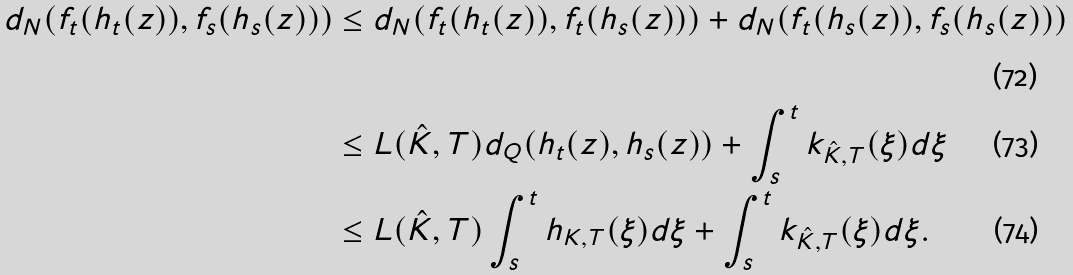<formula> <loc_0><loc_0><loc_500><loc_500>d _ { N } ( f _ { t } ( h _ { t } ( z ) ) , f _ { s } ( h _ { s } ( z ) ) ) & \leq d _ { N } ( f _ { t } ( h _ { t } ( z ) ) , f _ { t } ( h _ { s } ( z ) ) ) + d _ { N } ( f _ { t } ( h _ { s } ( z ) ) , f _ { s } ( h _ { s } ( z ) ) ) \\ & \leq L ( \hat { K } , T ) d _ { Q } ( h _ { t } ( z ) , h _ { s } ( z ) ) + \int _ { s } ^ { t } k _ { \hat { K } , T } ( \xi ) d \xi \\ & \leq L ( \hat { K } , T ) \int _ { s } ^ { t } h _ { K , T } ( \xi ) d \xi + \int _ { s } ^ { t } k _ { \hat { K } , T } ( \xi ) d \xi .</formula> 